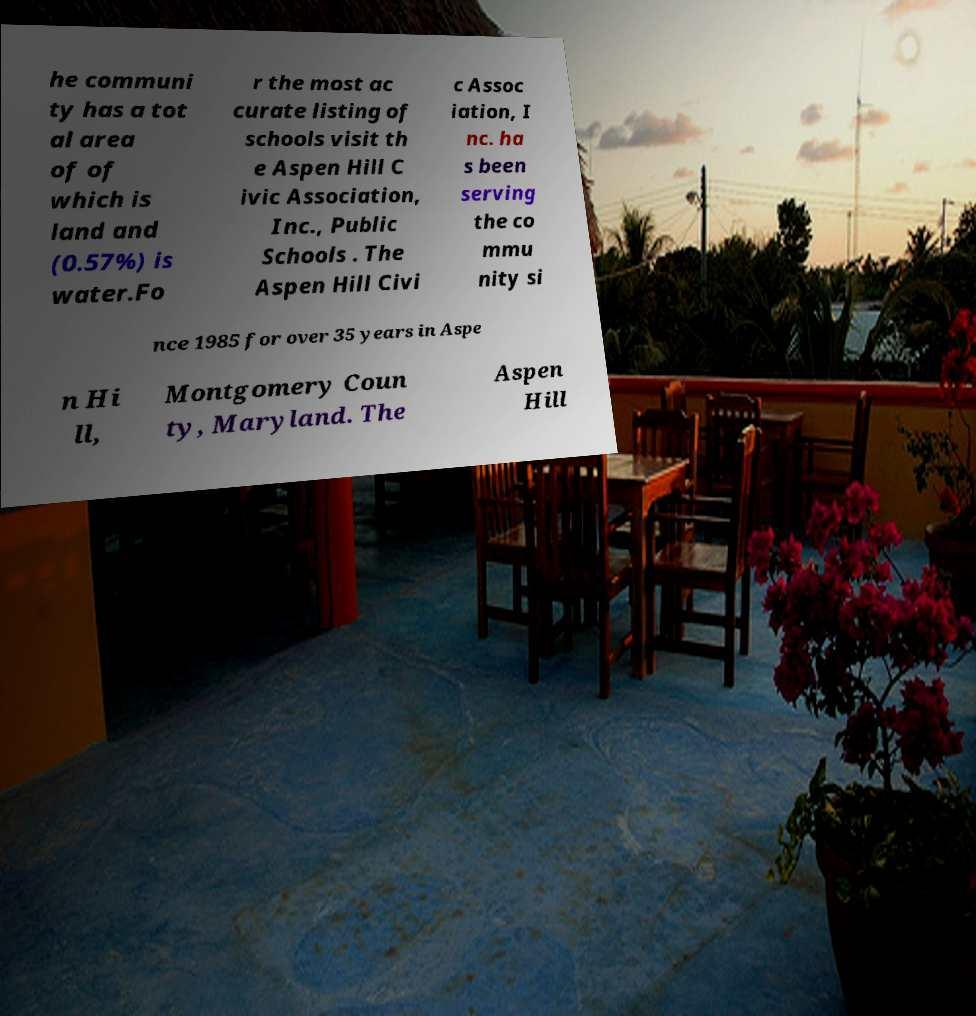For documentation purposes, I need the text within this image transcribed. Could you provide that? he communi ty has a tot al area of of which is land and (0.57%) is water.Fo r the most ac curate listing of schools visit th e Aspen Hill C ivic Association, Inc., Public Schools . The Aspen Hill Civi c Assoc iation, I nc. ha s been serving the co mmu nity si nce 1985 for over 35 years in Aspe n Hi ll, Montgomery Coun ty, Maryland. The Aspen Hill 